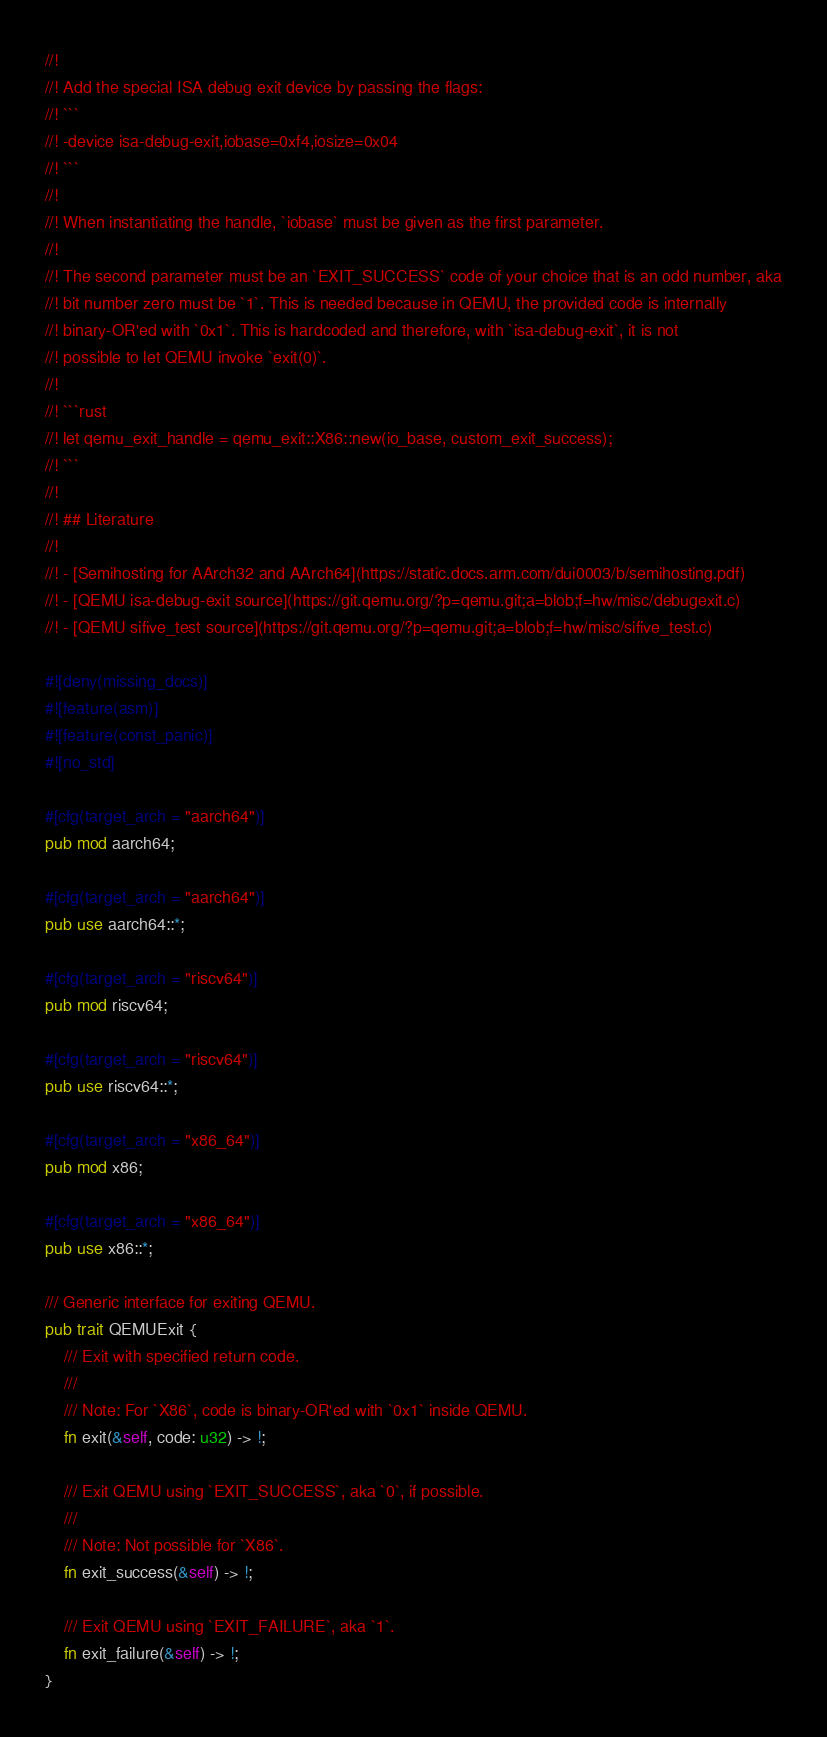<code> <loc_0><loc_0><loc_500><loc_500><_Rust_>//!
//! Add the special ISA debug exit device by passing the flags:
//! ```
//! -device isa-debug-exit,iobase=0xf4,iosize=0x04
//! ```
//!
//! When instantiating the handle, `iobase` must be given as the first parameter.
//!
//! The second parameter must be an `EXIT_SUCCESS` code of your choice that is an odd number, aka
//! bit number zero must be `1`. This is needed because in QEMU, the provided code is internally
//! binary-OR'ed with `0x1`. This is hardcoded and therefore, with `isa-debug-exit`, it is not
//! possible to let QEMU invoke `exit(0)`.
//!
//! ```rust
//! let qemu_exit_handle = qemu_exit::X86::new(io_base, custom_exit_success);
//! ```
//!
//! ## Literature
//!
//! - [Semihosting for AArch32 and AArch64](https://static.docs.arm.com/dui0003/b/semihosting.pdf)
//! - [QEMU isa-debug-exit source](https://git.qemu.org/?p=qemu.git;a=blob;f=hw/misc/debugexit.c)
//! - [QEMU sifive_test source](https://git.qemu.org/?p=qemu.git;a=blob;f=hw/misc/sifive_test.c)

#![deny(missing_docs)]
#![feature(asm)]
#![feature(const_panic)]
#![no_std]

#[cfg(target_arch = "aarch64")]
pub mod aarch64;

#[cfg(target_arch = "aarch64")]
pub use aarch64::*;

#[cfg(target_arch = "riscv64")]
pub mod riscv64;

#[cfg(target_arch = "riscv64")]
pub use riscv64::*;

#[cfg(target_arch = "x86_64")]
pub mod x86;

#[cfg(target_arch = "x86_64")]
pub use x86::*;

/// Generic interface for exiting QEMU.
pub trait QEMUExit {
    /// Exit with specified return code.
    ///
    /// Note: For `X86`, code is binary-OR'ed with `0x1` inside QEMU.
    fn exit(&self, code: u32) -> !;

    /// Exit QEMU using `EXIT_SUCCESS`, aka `0`, if possible.
    ///
    /// Note: Not possible for `X86`.
    fn exit_success(&self) -> !;

    /// Exit QEMU using `EXIT_FAILURE`, aka `1`.
    fn exit_failure(&self) -> !;
}
</code> 